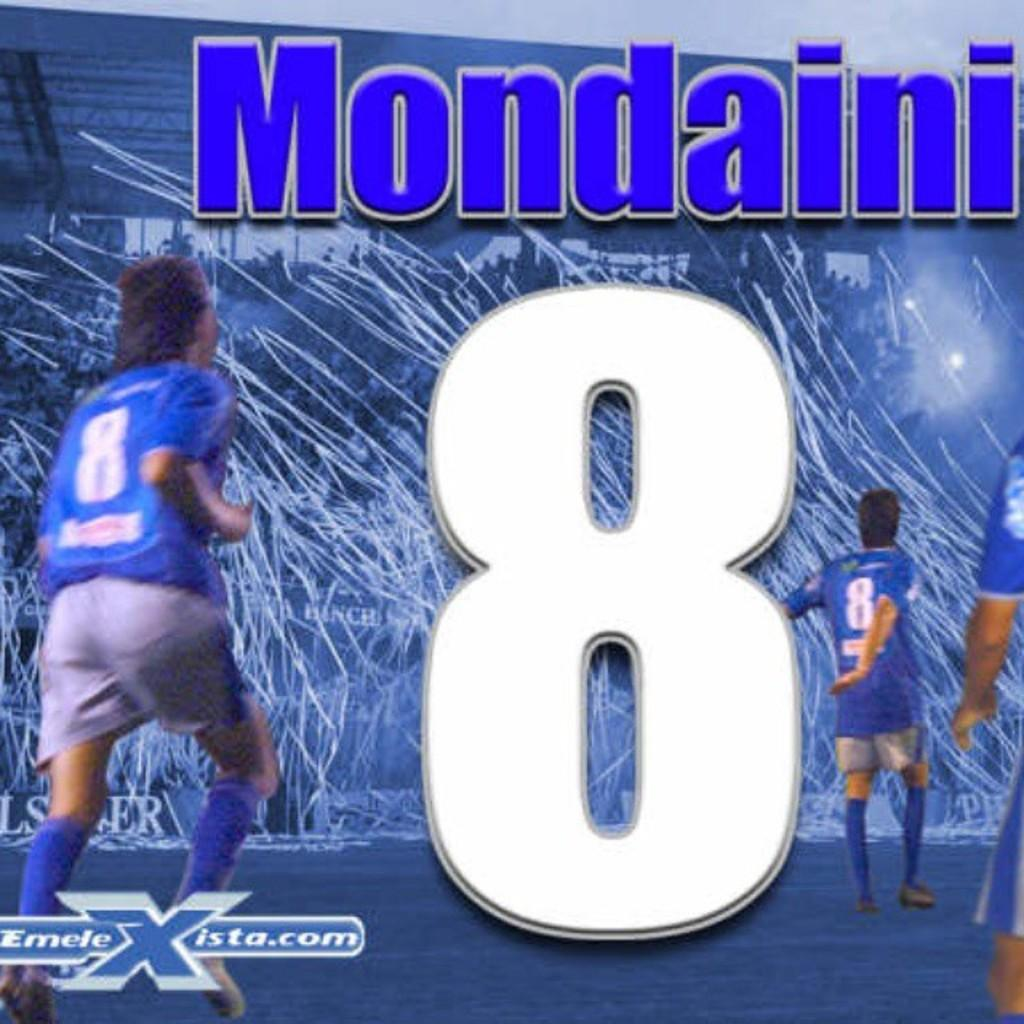<image>
Present a compact description of the photo's key features. Mondaini is wearing a number 8 jersey and streamers are coming out of the stands. 